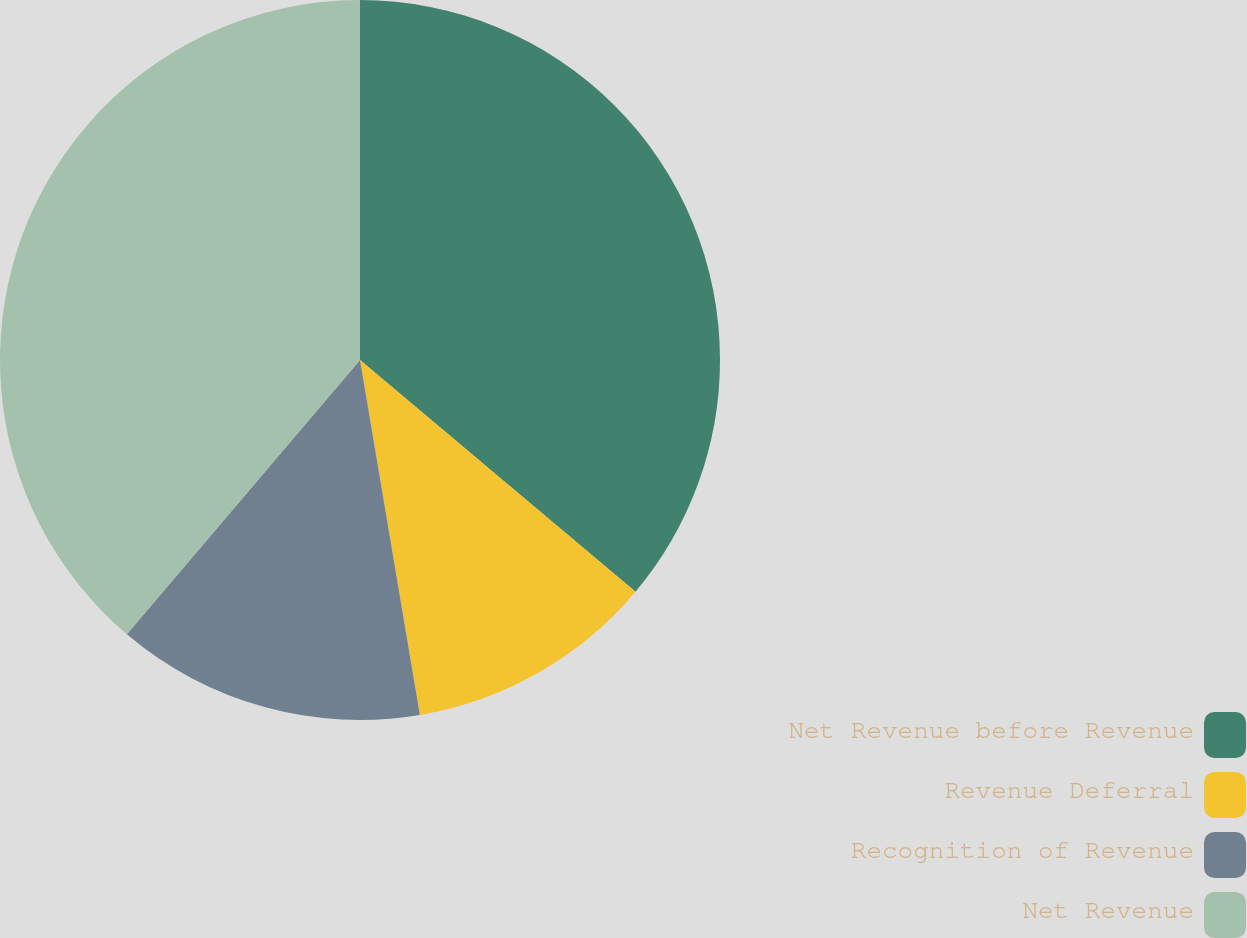Convert chart to OTSL. <chart><loc_0><loc_0><loc_500><loc_500><pie_chart><fcel>Net Revenue before Revenue<fcel>Revenue Deferral<fcel>Recognition of Revenue<fcel>Net Revenue<nl><fcel>36.13%<fcel>11.21%<fcel>13.87%<fcel>38.79%<nl></chart> 